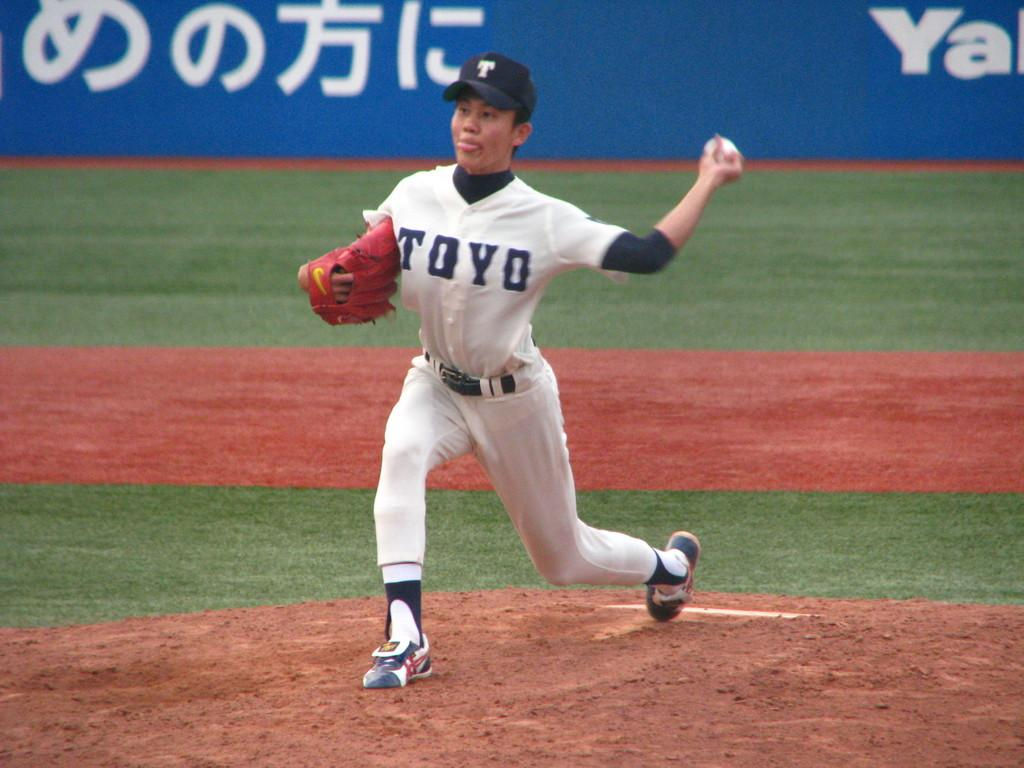<image>
Offer a succinct explanation of the picture presented. A baseball player wears a jersey that says TOYO. 